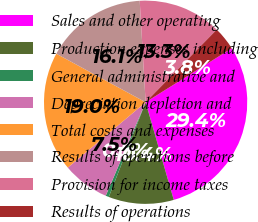<chart> <loc_0><loc_0><loc_500><loc_500><pie_chart><fcel>Sales and other operating<fcel>Production expenses including<fcel>General administrative and<fcel>Depreciation depletion and<fcel>Total costs and expenses<fcel>Results of operations before<fcel>Provision for income taxes<fcel>Results of operations<nl><fcel>29.44%<fcel>10.37%<fcel>0.51%<fcel>7.47%<fcel>19.04%<fcel>16.15%<fcel>13.26%<fcel>3.76%<nl></chart> 